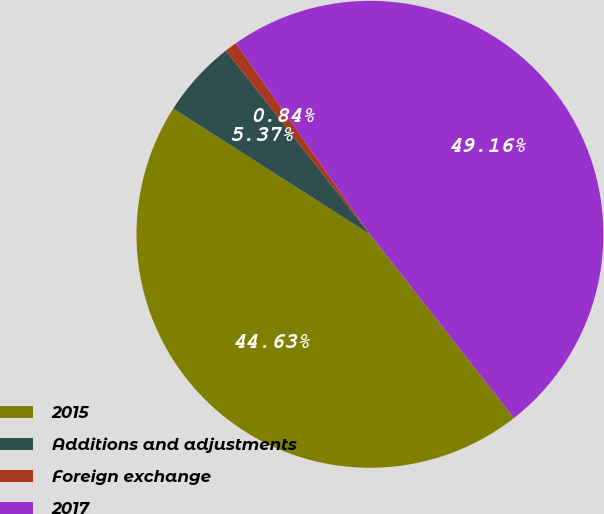<chart> <loc_0><loc_0><loc_500><loc_500><pie_chart><fcel>2015<fcel>Additions and adjustments<fcel>Foreign exchange<fcel>2017<nl><fcel>44.63%<fcel>5.37%<fcel>0.84%<fcel>49.16%<nl></chart> 